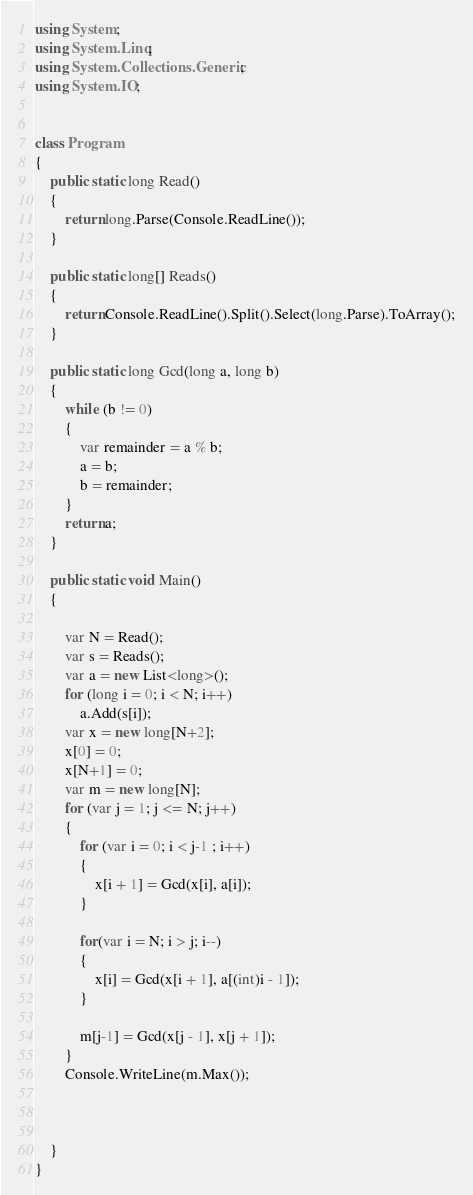Convert code to text. <code><loc_0><loc_0><loc_500><loc_500><_C#_>using System;
using System.Linq;
using System.Collections.Generic;
using System.IO;


class Program
{
    public static long Read()
    {
        return long.Parse(Console.ReadLine());
    }

    public static long[] Reads()
    {
        return Console.ReadLine().Split().Select(long.Parse).ToArray();
    }

    public static long Gcd(long a, long b)
    {
        while (b != 0)
        {
            var remainder = a % b;
            a = b;
            b = remainder;
        }
        return a;
    }

    public static void Main()
    {
        
        var N = Read();
        var s = Reads();
        var a = new List<long>();
        for (long i = 0; i < N; i++)
            a.Add(s[i]);
        var x = new long[N+2];
        x[0] = 0;
        x[N+1] = 0;
        var m = new long[N];
        for (var j = 1; j <= N; j++)
        {
            for (var i = 0; i < j-1 ; i++)
            {
                x[i + 1] = Gcd(x[i], a[i]);
            }

            for(var i = N; i > j; i--)
            {
                x[i] = Gcd(x[i + 1], a[(int)i - 1]);
            }

            m[j-1] = Gcd(x[j - 1], x[j + 1]);
        }
        Console.WriteLine(m.Max());


        
    }
}
</code> 